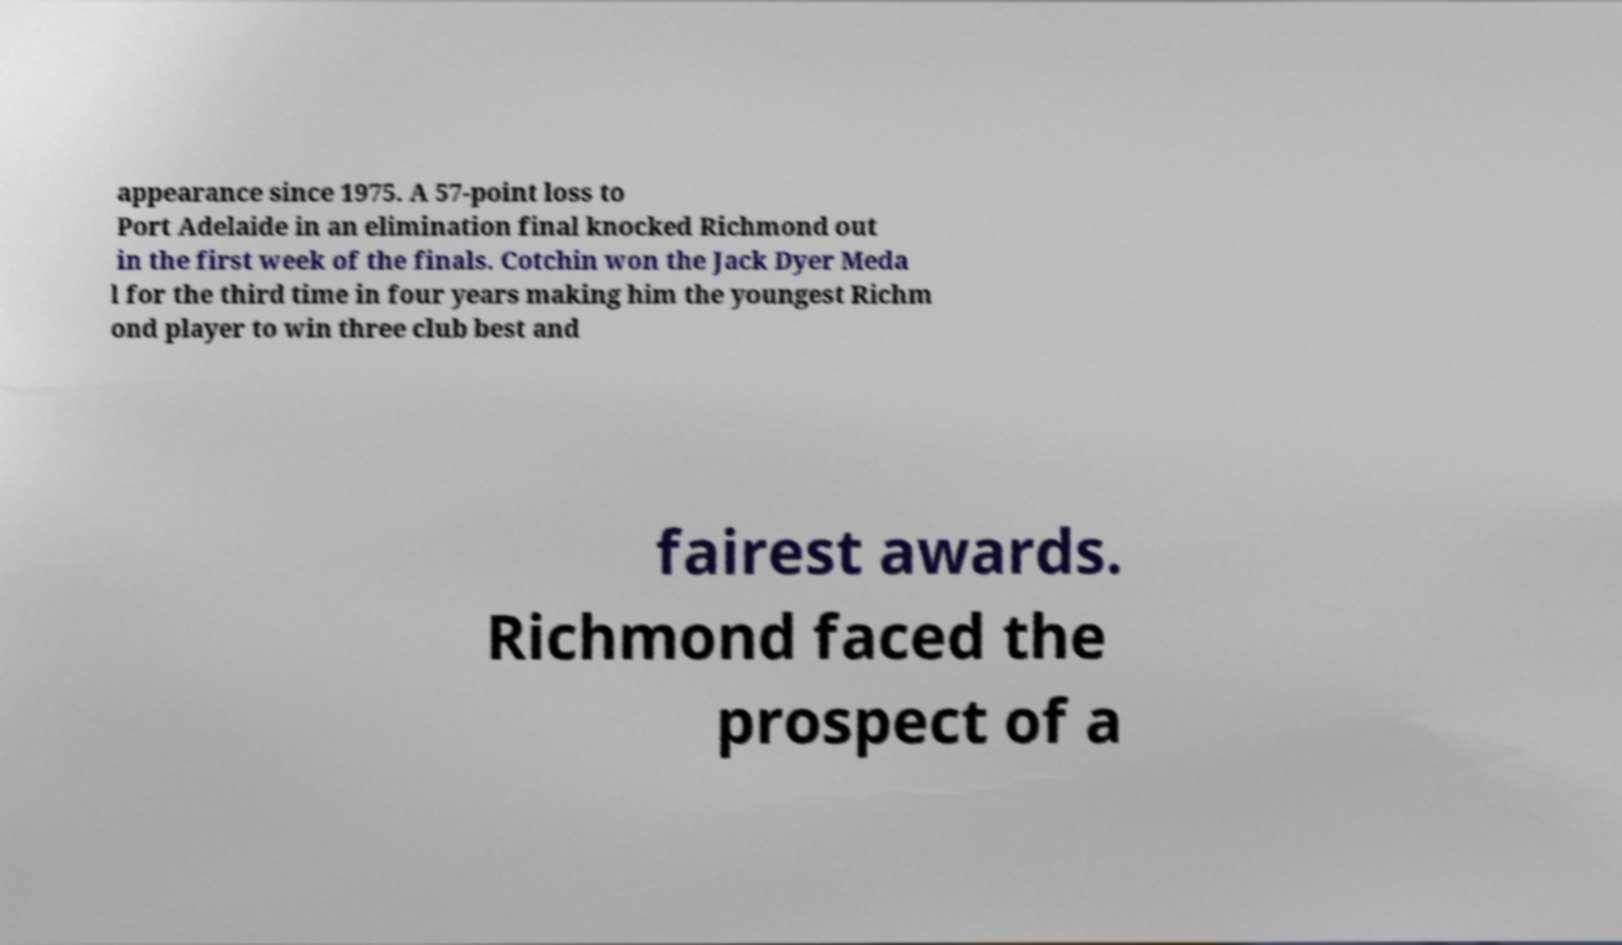Can you accurately transcribe the text from the provided image for me? appearance since 1975. A 57-point loss to Port Adelaide in an elimination final knocked Richmond out in the first week of the finals. Cotchin won the Jack Dyer Meda l for the third time in four years making him the youngest Richm ond player to win three club best and fairest awards. Richmond faced the prospect of a 